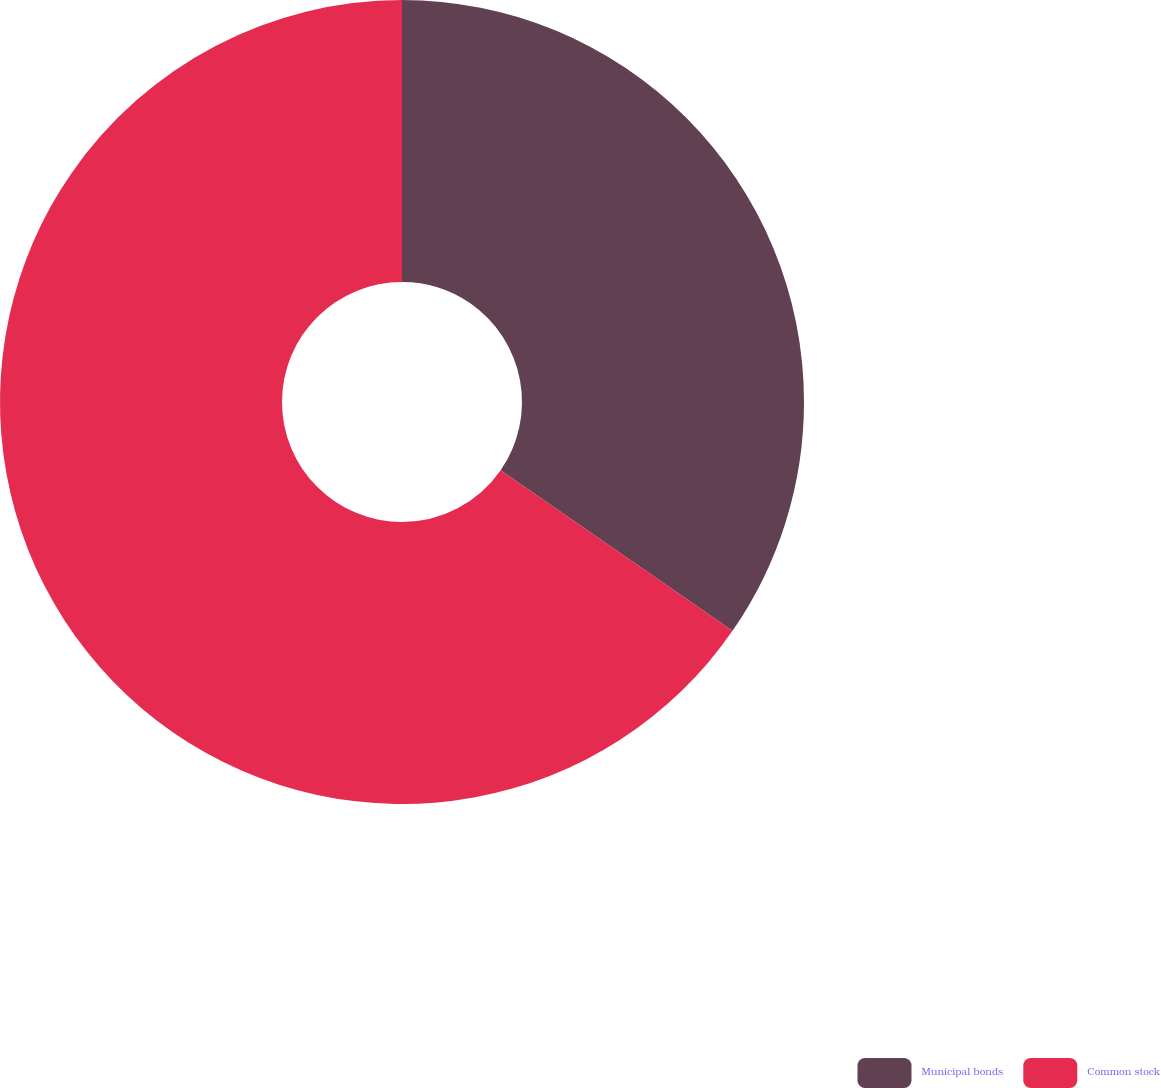<chart> <loc_0><loc_0><loc_500><loc_500><pie_chart><fcel>Municipal bonds<fcel>Common stock<nl><fcel>34.64%<fcel>65.36%<nl></chart> 